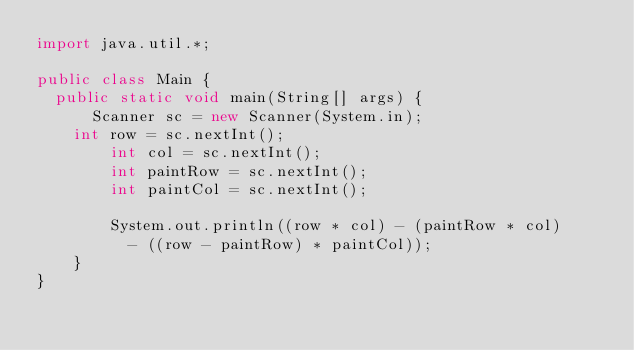<code> <loc_0><loc_0><loc_500><loc_500><_Java_>import java.util.*;

public class Main {
	public static void main(String[] args) {  
  		Scanner sc = new Scanner(System.in);
		int row = sc.nextInt();
      	int col = sc.nextInt();
      	int paintRow = sc.nextInt();
      	int paintCol = sc.nextInt();
      
      	System.out.println((row * col) - (paintRow * col)
        	- ((row - paintRow) * paintCol));
    }
}</code> 